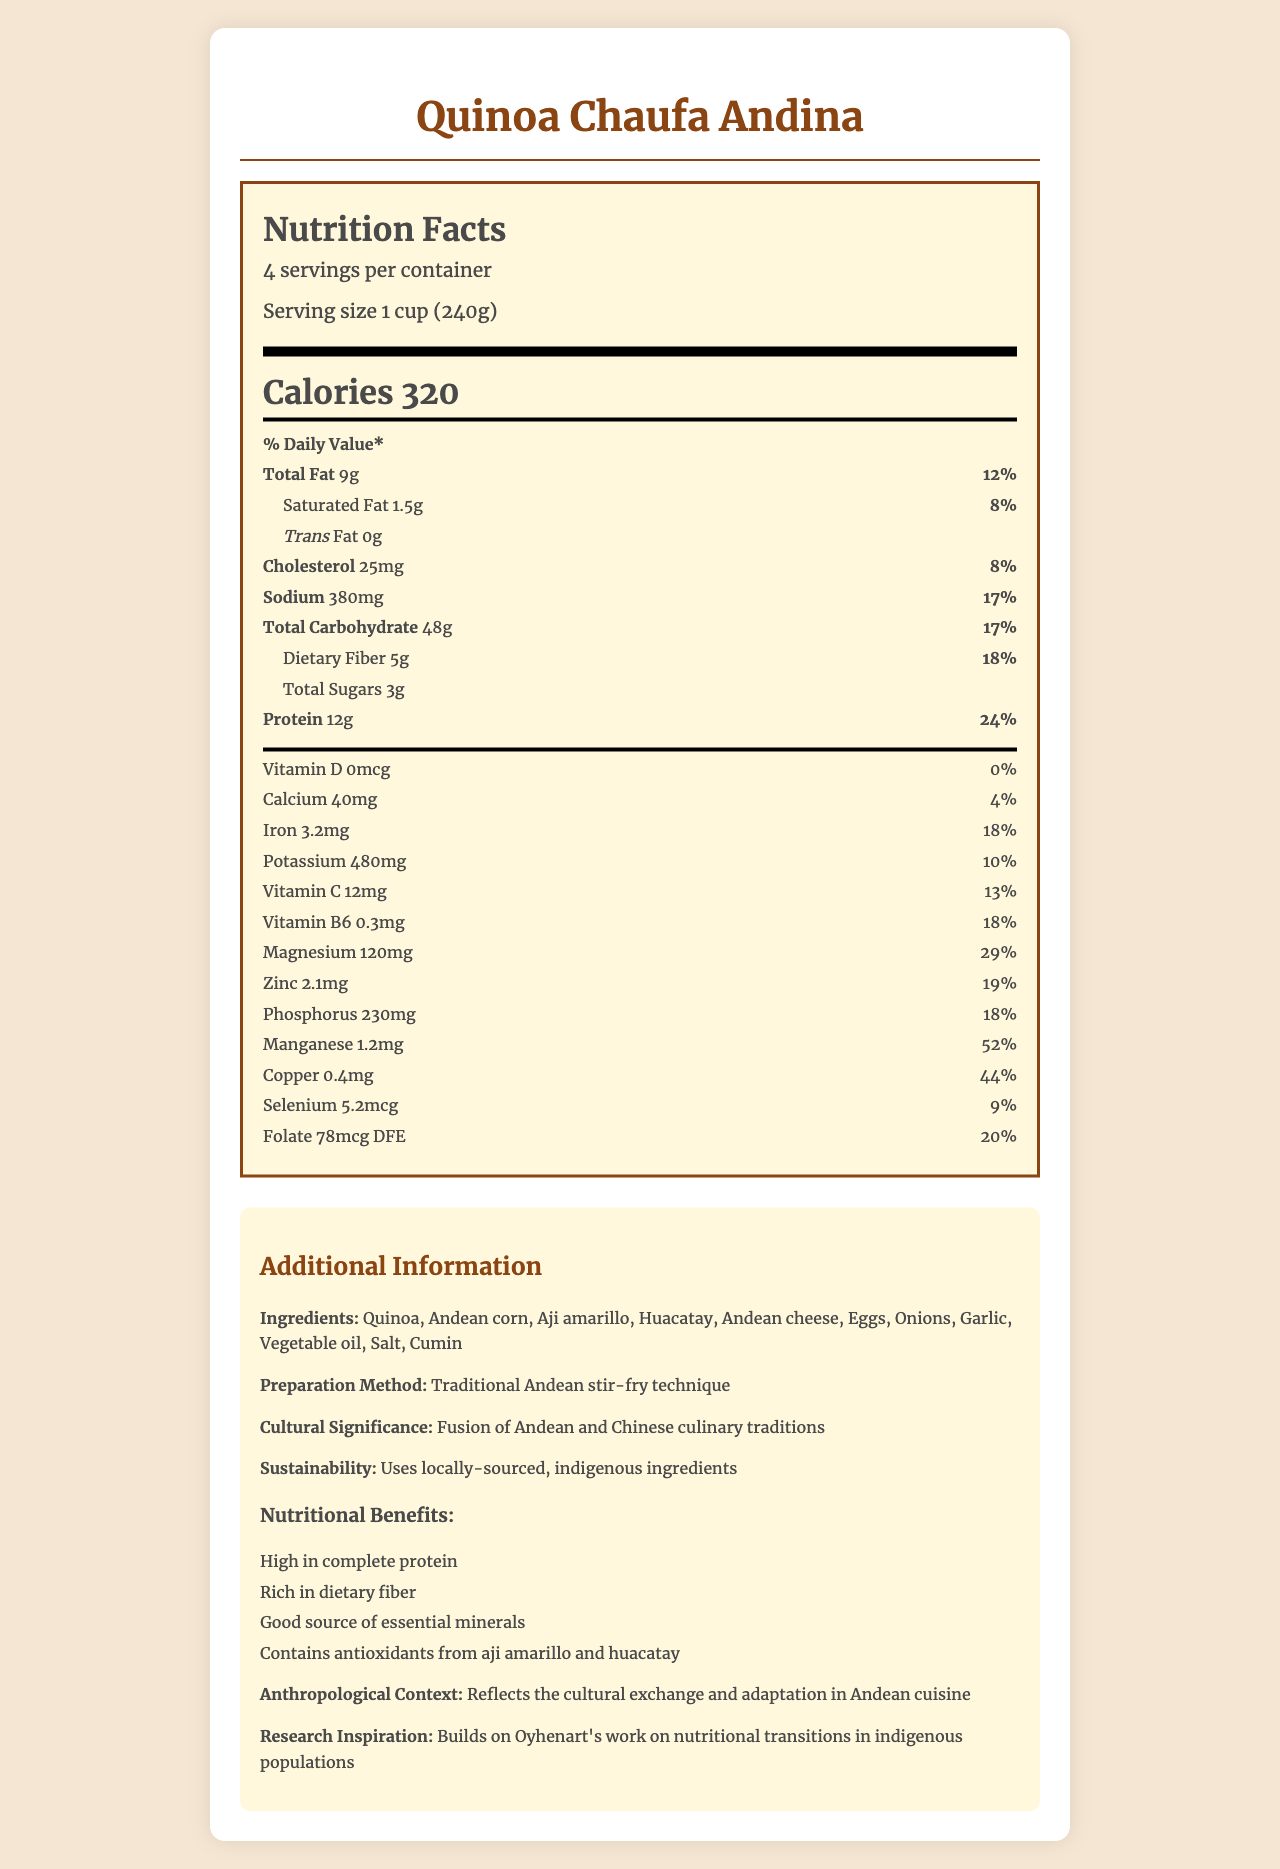What is the serving size for Quinoa Chaufa Andina? The serving size is explicitly listed as "1 cup (240g)" in the document.
Answer: 1 cup (240g) How many servings are there per container? The document states that there are 4 servings per container.
Answer: 4 What is the amount of protein per serving? The amount of protein per serving is clearly listed as 12g.
Answer: 12g What is the daily value percentage for magnesium? The daily value percentage for magnesium is listed as 29%.
Answer: 29% What are the main ingredients of Quinoa Chaufa Andina? The document lists these ingredients explicitly under "Ingredients".
Answer: Quinoa, Andean corn, Aji amarillo, Huacatay, Andean cheese, Eggs, Onions, Garlic, Vegetable oil, Salt, Cumin Which nutrient has the highest daily value percentage? A. Vitamin C B. Iron C. Magnesium D. Manganese Manganese has the highest daily value percentage at 52%, compared to other nutrients.
Answer: D. Manganese What is the daily value percentage for calcium? A. 10% B. 13% C. 4% D. 18% The document states that the daily value percentage for calcium is 4%.
Answer: C. 4% Does the dish contain any trans fat? The document lists the trans fat amount as 0g.
Answer: No Is the amount of cholesterol in the serving high? The amount of cholesterol is 25mg, which is only 8% of the daily value, indicating it is relatively low.
Answer: No Summarize the document This summary captures the key elements and focus of the document: Nutrition facts, ingredients, preparation method, cultural significance, and additional nutritional insights.
Answer: The document provides a detailed Nutrition Facts Label for Quinoa Chaufa Andina, listing macronutrient and micronutrient content per serving, daily value percentages, and additional information about ingredients, preparation methods, cultural significance, sustainability, and nutritional benefits. What culinary tradition does Quinoa Chaufa Andina reflect? The document explicitly states that the dish reflects a fusion of Andean and Chinese culinary traditions under "Cultural Significance".
Answer: Fusion of Andean and Chinese culinary traditions What is the daily value percentage for dietary fiber? The daily value percentage for dietary fiber is 18%.
Answer: 18% Does the document mention the exact preparation time for the dish? The document does not provide any details on the preparation time of the dish.
Answer: Not enough information What is the additional benefit of the aji amarillo and huacatay ingredients? The document mentions that aji amarillo and huacatay contain antioxidants, which is part of the nutritional benefits.
Answer: Contains antioxidants Which of the following is not listed as a nutritional benefit? A. High in complete protein B. Low in cholesterol C. Rich in dietary fiber D. Good source of essential minerals While the dish is high in complete protein, rich in dietary fiber, and a good source of essential minerals, the document does not list "low in cholesterol" as one of the benefits.
Answer: B. Low in cholesterol 